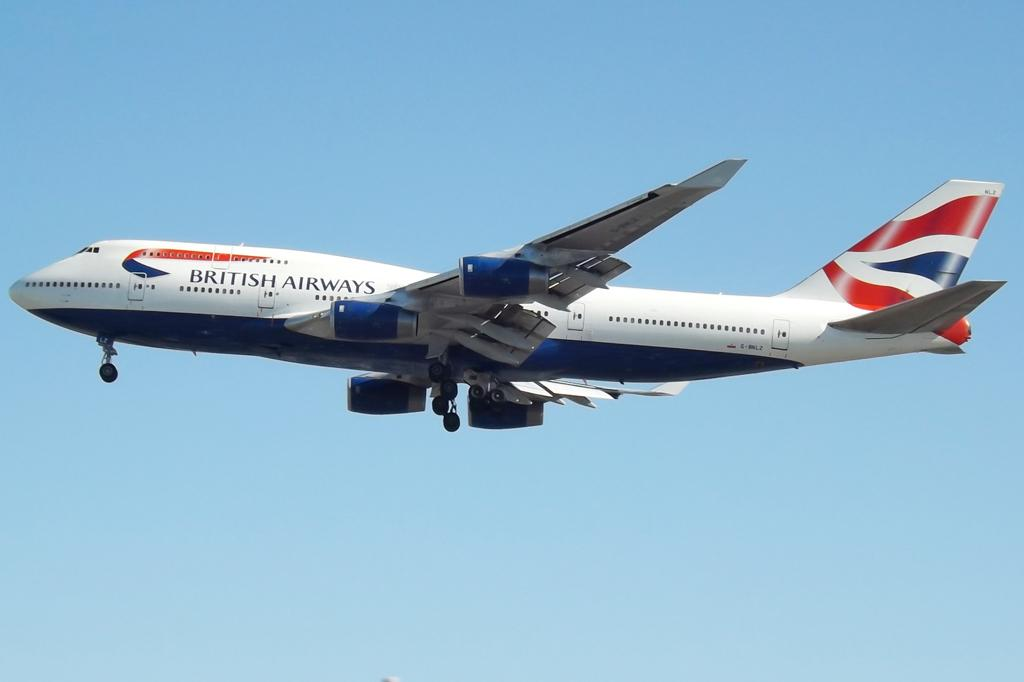<image>
Create a compact narrative representing the image presented. a plane with words on the side that read 'british airways' 